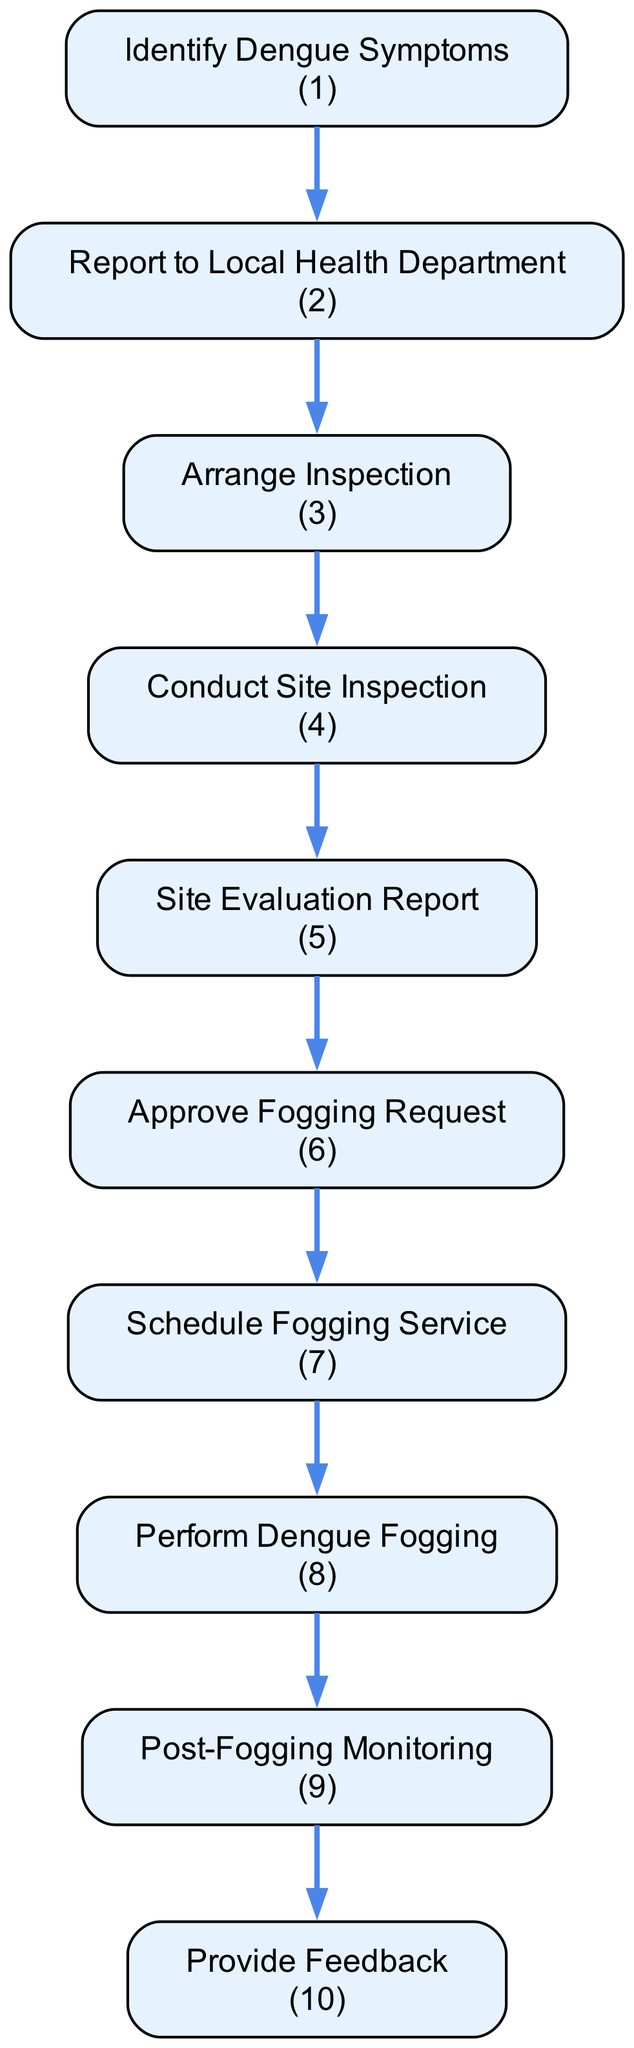What is the first step in the dengue fogging process? The first step is to "Identify Dengue Symptoms", which involves the citizen noticing dengue symptoms in themselves or others.
Answer: Identify Dengue Symptoms How many steps are involved in the process? Counting all the nodes in the diagram, there are ten distinct steps involved in the process from identifying symptoms to providing feedback.
Answer: 10 What action follows reporting to the local health department? After reporting to the local health department, the next action is to "Arrange Inspection" to assess the suspected dengue cases.
Answer: Arrange Inspection What is generated after conducting the site inspection? After conducting the site inspection, a "Site Evaluation Report" is generated detailing the findings regarding the mosquito problem and potential outbreak risks.
Answer: Site Evaluation Report If the site evaluation indicates a high risk, what does the health department do next? If the site evaluation indicates a high risk of dengue outbreak, the health department moves to "Approve Fogging Request", allowing fogging services to be requested.
Answer: Approve Fogging Request Which step follows the scheduling of the fogging service? The step that follows the scheduling of the fogging service is the "Perform Dengue Fogging", where actual fogging operations are carried out.
Answer: Perform Dengue Fogging What is the last step in the dengue fogging process? The last step in the process is "Provide Feedback," which allows the concerned citizen to communicate their thoughts on the effectiveness of the fogging service.
Answer: Provide Feedback What do health officials monitor after the fogging service is performed? After the fogging service is performed, health officials monitor the area to assess effectiveness and check for a rebound in the mosquito population.
Answer: Post-Fogging Monitoring What do citizens need to do after noticing dengue symptoms? After noticing dengue symptoms, citizens need to "Report to Local Health Department" by contacting them via phone or online.
Answer: Report to Local Health Department What indicates that fogging services will be approved? Fogging services will be approved if the site evaluation report confirms a "high risk of dengue outbreak."
Answer: high risk of dengue outbreak 